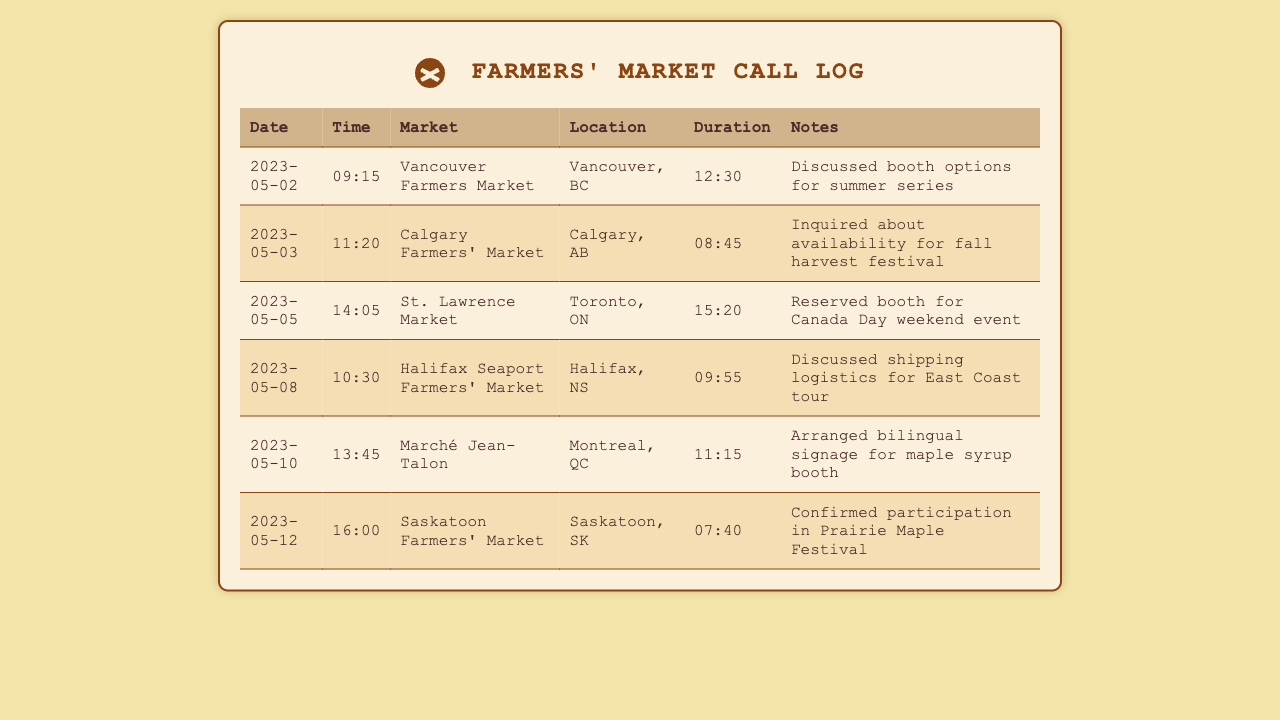What is the date of the call to the Vancouver Farmers Market? The date can be found in the first row of the table under the Date column.
Answer: 2023-05-02 What was discussed during the call to the Calgary Farmers' Market? The discussion topic is detailed in the Notes column for the corresponding row.
Answer: Inquired about availability for fall harvest festival How long was the call to the St. Lawrence Market? The duration of the call is located in the Duration column of the table.
Answer: 15:20 Which market confirmed participation in the Prairie Maple Festival? The market is indicated in the Notes column for the Saskatoon Farmers' Market entry.
Answer: Saskatoon Farmers' Market Which province is the Halifax Seaport Farmers' Market located in? The province can be found in the Location column next to the market name.
Answer: Nova Scotia What is the total duration of the call to Marché Jean-Talon? The call duration can be found in the Duration column associated with Marché Jean-Talon.
Answer: 11:15 How many calls were made in total? Total calls are determined by counting the number of rows in the table.
Answer: 6 What time was the call to the Saskatoon Farmers' Market? The time of the call is stated in the Time column for that market.
Answer: 16:00 What is the location of the Calgary Farmers' Market? The location is listed in the Location column corresponding to the Calgary Farmers' Market entry.
Answer: Calgary, AB 